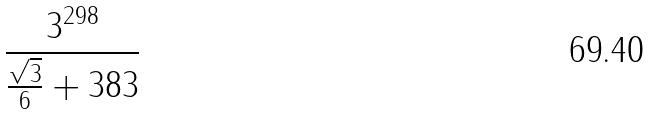Convert formula to latex. <formula><loc_0><loc_0><loc_500><loc_500>\frac { 3 ^ { 2 9 8 } } { \frac { \sqrt { 3 } } { 6 } + 3 8 3 }</formula> 